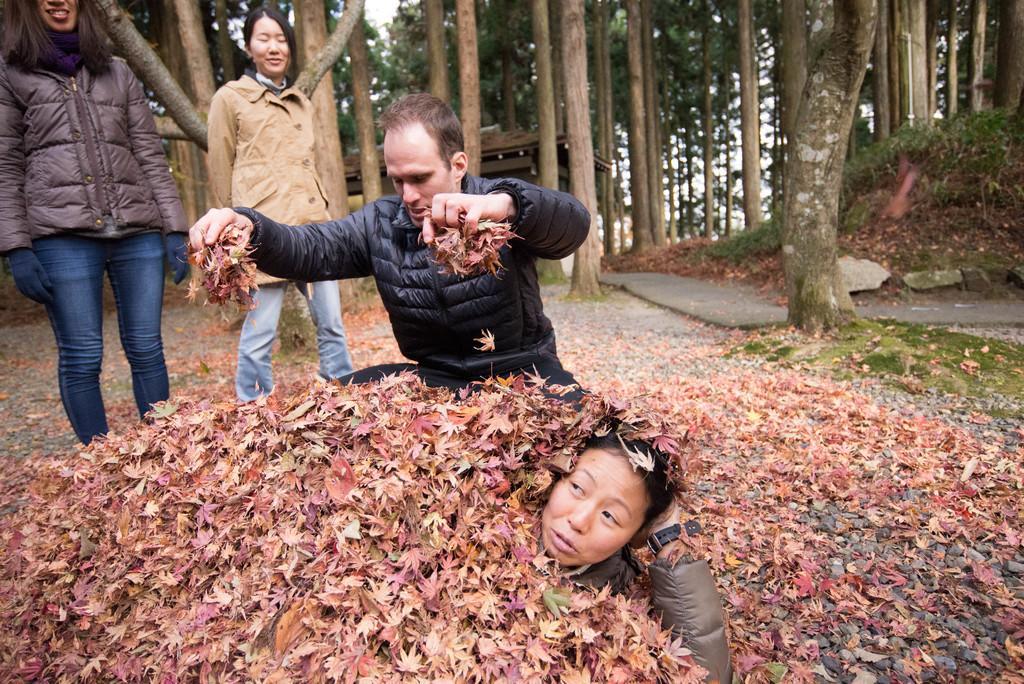Could you give a brief overview of what you see in this image? In this image a person is lying on the land. He is covered with leaves. Behind a person is holding few dried leaves in his hand. Left side two women are standing on the land. Background there are few trees. Right side there is a road. 